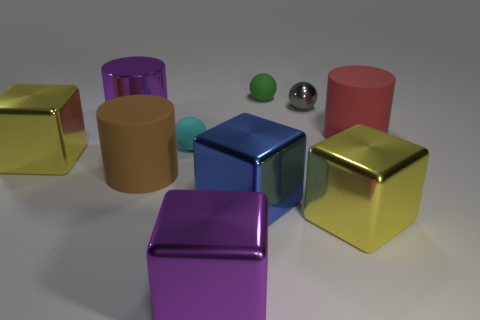Can you describe the arrangement and colors of the objects presented? In the image, there is an array of geometric shapes in various colors. A purple metal cube, golden and red reflective cubes, along with a blue cube, are scattered across the surface. A small green rubber ball and a red cylinder are also visible. In the center, there's a small matte sphere with a metallic sphere in front of it. 